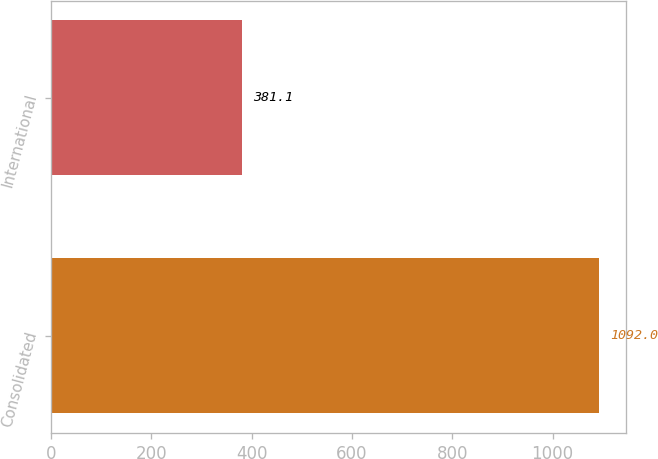<chart> <loc_0><loc_0><loc_500><loc_500><bar_chart><fcel>Consolidated<fcel>International<nl><fcel>1092<fcel>381.1<nl></chart> 